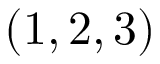Convert formula to latex. <formula><loc_0><loc_0><loc_500><loc_500>( 1 , 2 , 3 )</formula> 